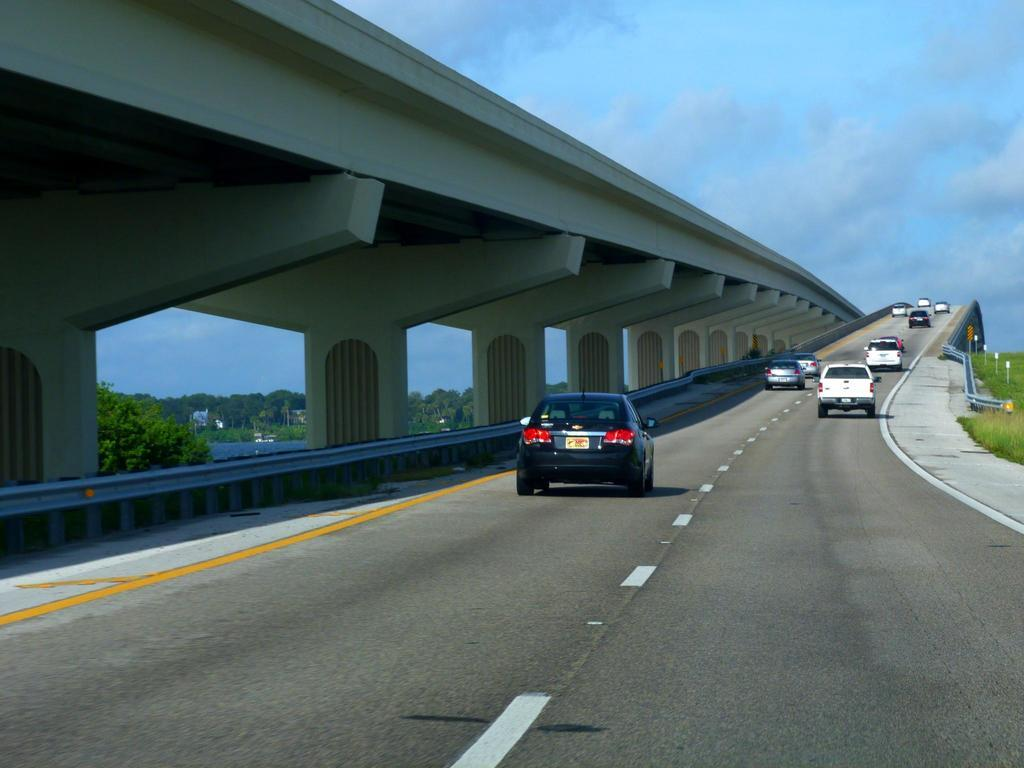What can be seen on the road in the image? There are many vehicles on the road in the image. What structure is present in the image that allows vehicles to cross over a body of water or land? There is a bridge in the image. What type of natural vegetation is visible in the image? There are trees in the image. What type of man-made structures can be seen in the image? There are poles in the image. How would you describe the weather based on the image? The sky is cloudy in the image, which suggests overcast or potentially rainy weather. What type of grain is being harvested in the image? There is no grain present in the image; it features vehicles on a road, a bridge, trees, poles, and a cloudy sky. What type of railway system can be seen in the image? There is no railway system present in the image; it features vehicles on a road, a bridge, trees, poles, and a cloudy sky. 